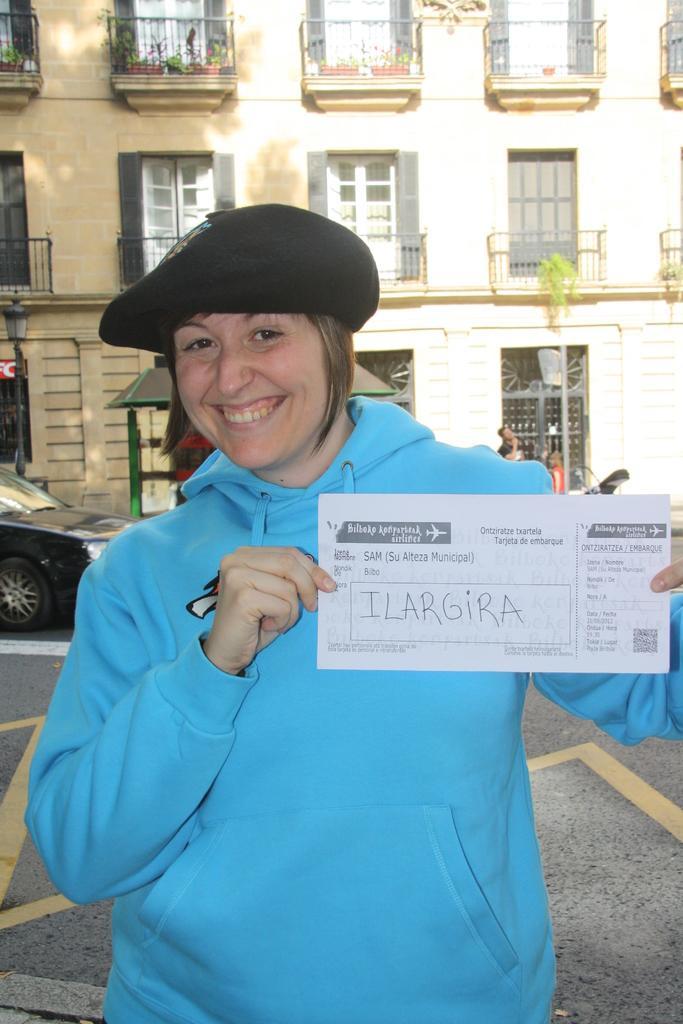Please provide a concise description of this image. In this image I can see a person is holding paper and wearing blue top and black cap. Back Side I can see building and windows. I can see a light-pole and vehicle on the road. 